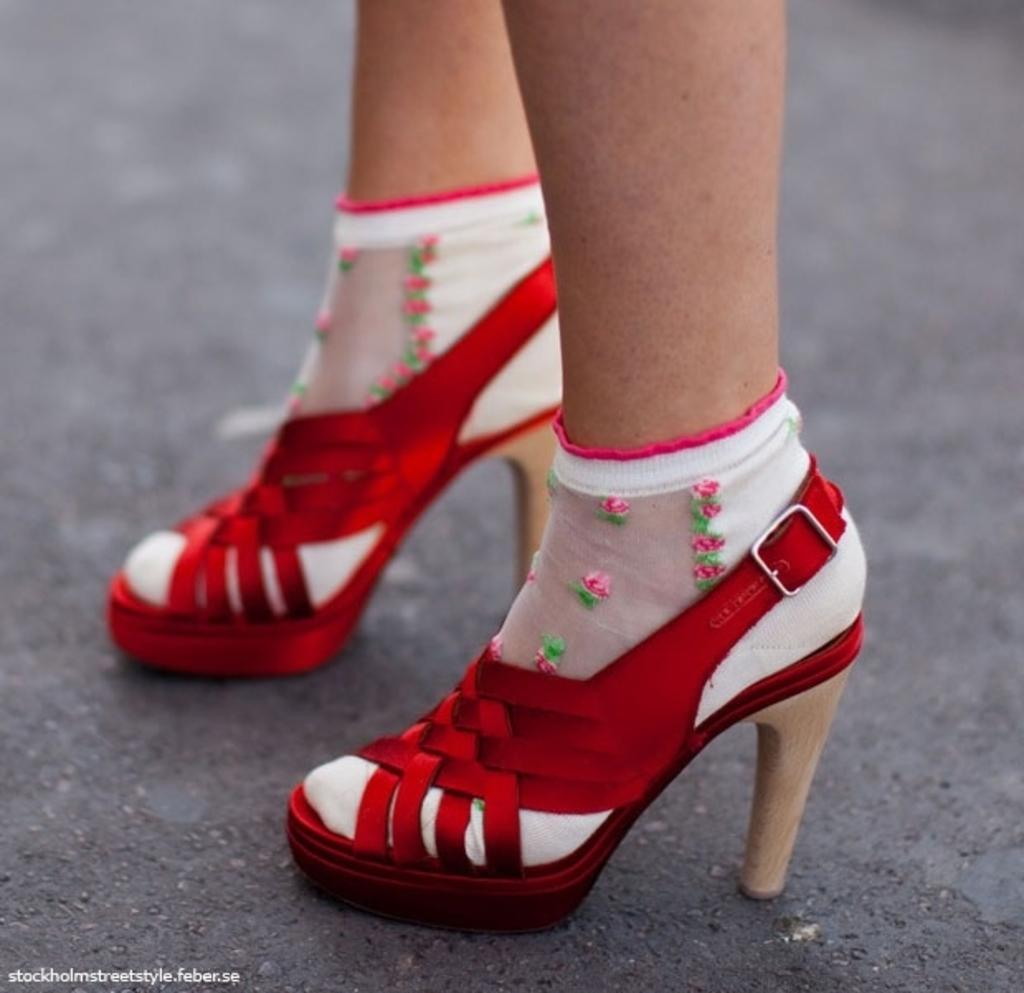What part of a person can be seen in the image? There are legs of a person visible in the image. Where are the person's legs located? The person's legs are on the road. What type of footwear is the person wearing? The person is wearing worn footwear. What can be found at the bottom of the image? There is text at the bottom of the image. What songs can be heard playing in the park in the image? There is no park or indication of music playing in the image; it only shows a person's legs on the road. 